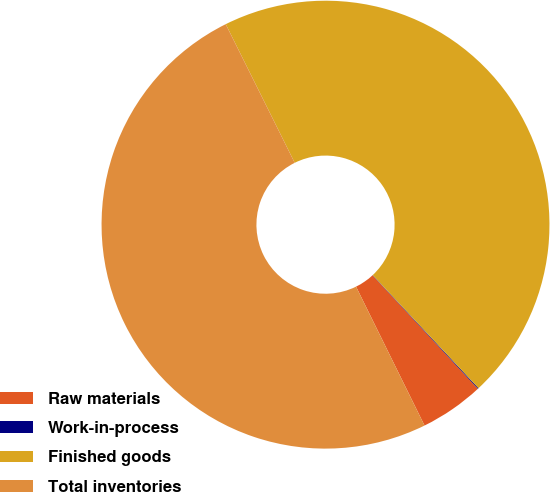Convert chart. <chart><loc_0><loc_0><loc_500><loc_500><pie_chart><fcel>Raw materials<fcel>Work-in-process<fcel>Finished goods<fcel>Total inventories<nl><fcel>4.62%<fcel>0.06%<fcel>45.38%<fcel>49.94%<nl></chart> 